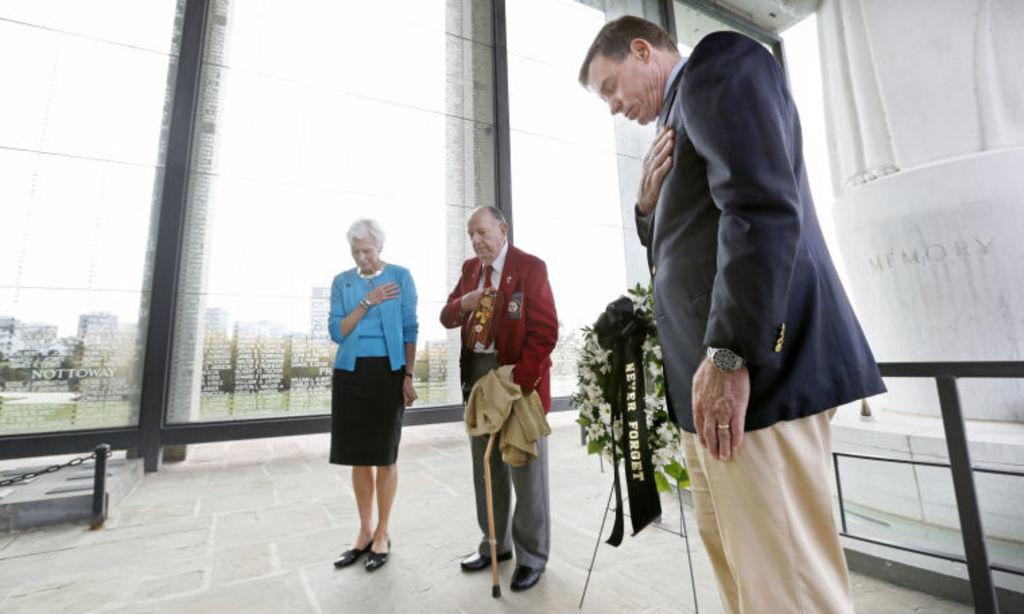What are the main subjects in the image? There are persons standing in the center of the image. Where are the persons standing? The persons are standing on the floor. What can be seen in the background of the image? There is a houseplant, windows, and a wall in the background of the image. What type of fang can be seen in the image? There is no fang present in the image. What kind of art is displayed on the wall in the image? There is no art displayed on the wall in the image. 